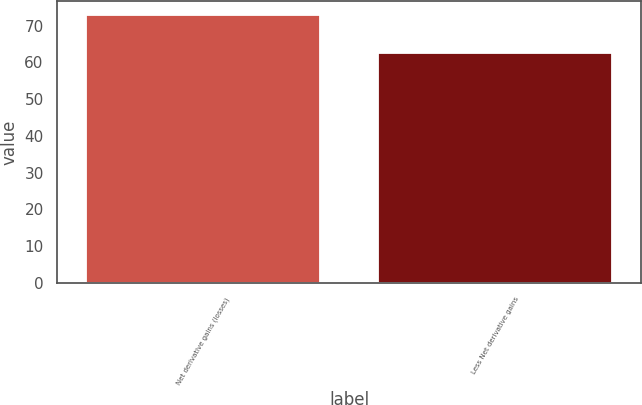Convert chart to OTSL. <chart><loc_0><loc_0><loc_500><loc_500><bar_chart><fcel>Net derivative gains (losses)<fcel>Less Net derivative gains<nl><fcel>73.04<fcel>62.66<nl></chart> 